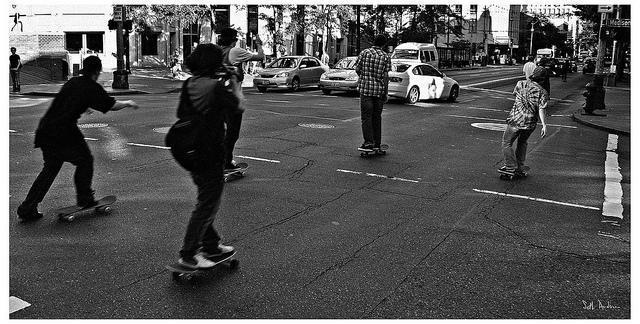How many people are there?
Give a very brief answer. 4. How many cars are there?
Give a very brief answer. 2. 